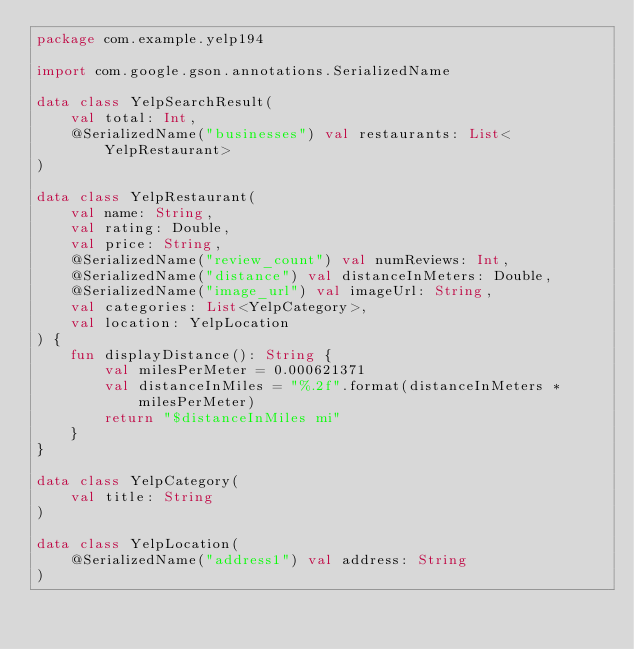<code> <loc_0><loc_0><loc_500><loc_500><_Kotlin_>package com.example.yelp194

import com.google.gson.annotations.SerializedName

data class YelpSearchResult(
    val total: Int,
    @SerializedName("businesses") val restaurants: List<YelpRestaurant>
)

data class YelpRestaurant(
    val name: String,
    val rating: Double,
    val price: String,
    @SerializedName("review_count") val numReviews: Int,
    @SerializedName("distance") val distanceInMeters: Double,
    @SerializedName("image_url") val imageUrl: String,
    val categories: List<YelpCategory>,
    val location: YelpLocation
) {
    fun displayDistance(): String {
        val milesPerMeter = 0.000621371
        val distanceInMiles = "%.2f".format(distanceInMeters * milesPerMeter)
        return "$distanceInMiles mi"
    }
}

data class YelpCategory(
    val title: String
)

data class YelpLocation(
    @SerializedName("address1") val address: String
)</code> 